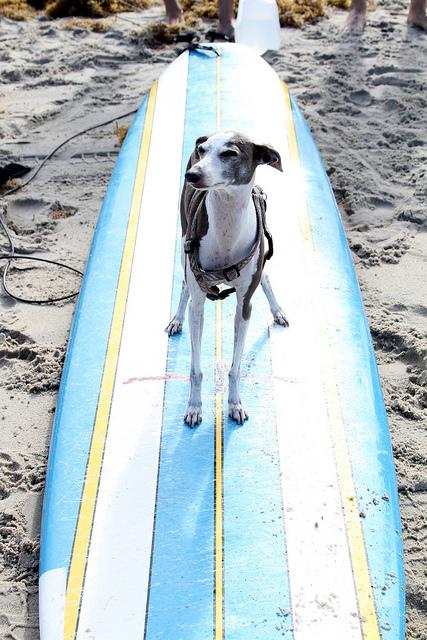Is the dog wearing a life vest?
Keep it brief. Yes. What is on the surfboard?
Concise answer only. Dog. Is the dog wearing a harness?
Give a very brief answer. Yes. 